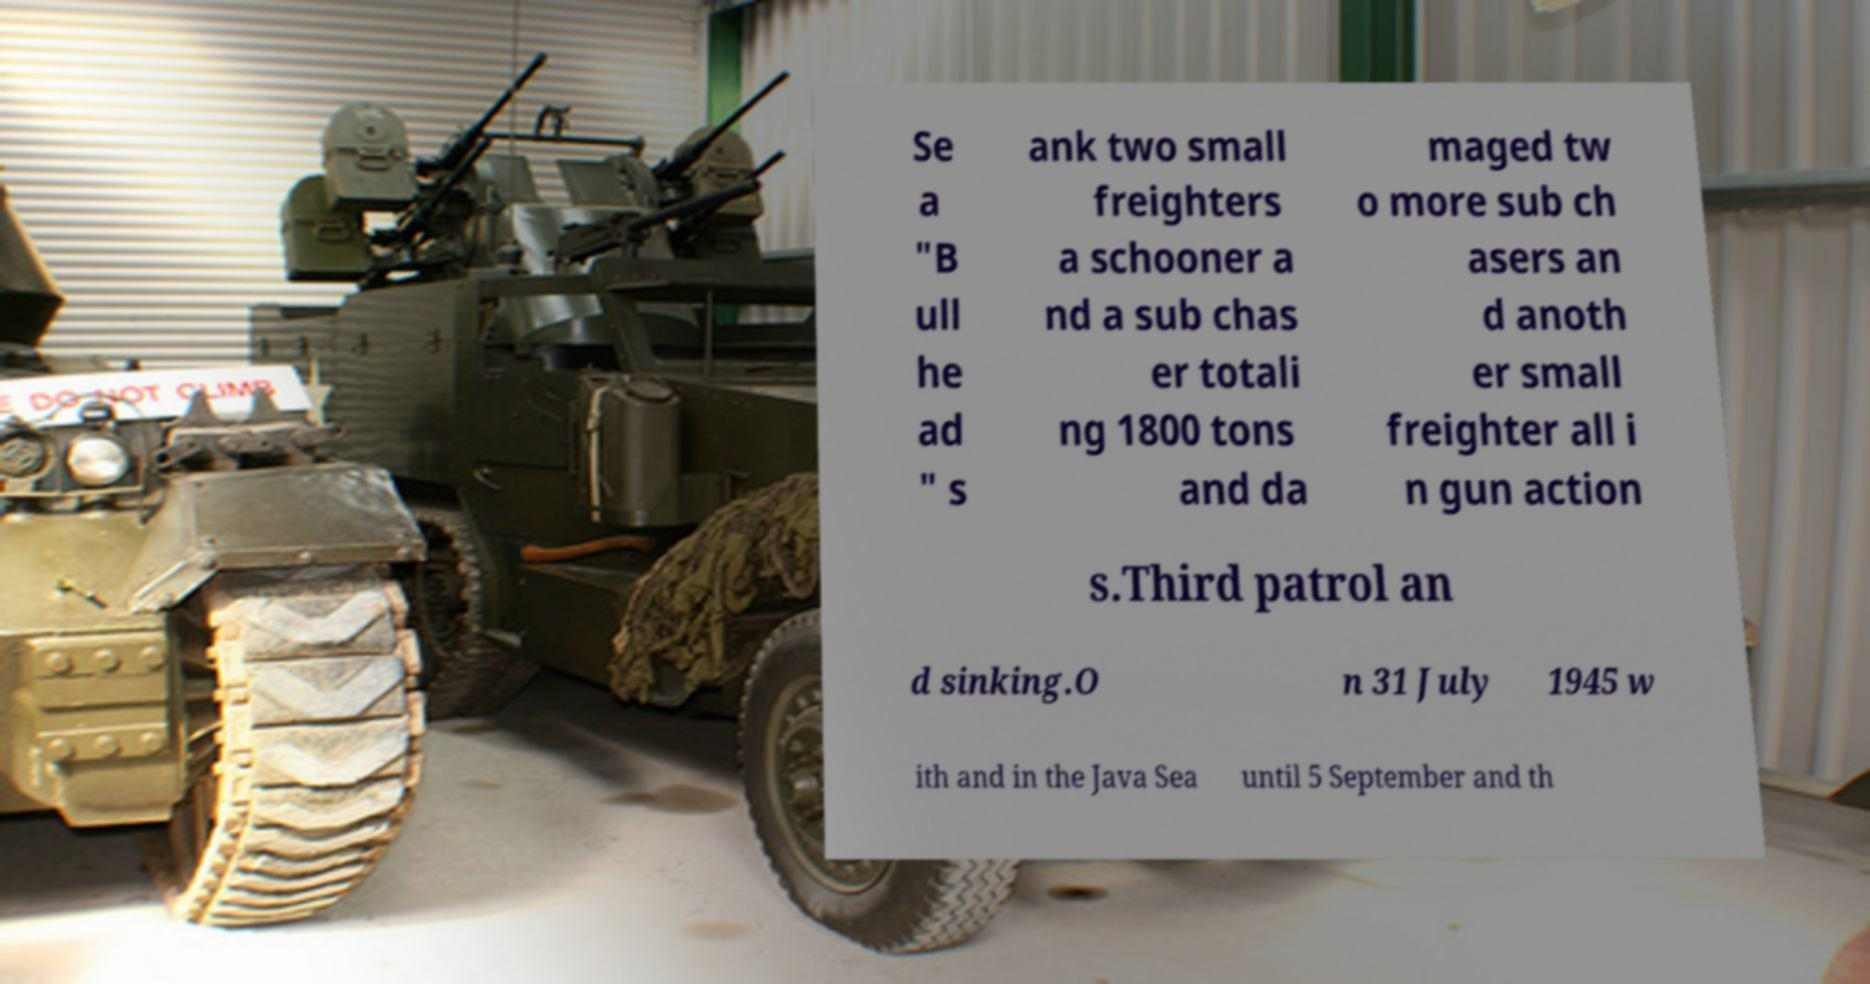What messages or text are displayed in this image? I need them in a readable, typed format. Se a "B ull he ad " s ank two small freighters a schooner a nd a sub chas er totali ng 1800 tons and da maged tw o more sub ch asers an d anoth er small freighter all i n gun action s.Third patrol an d sinking.O n 31 July 1945 w ith and in the Java Sea until 5 September and th 